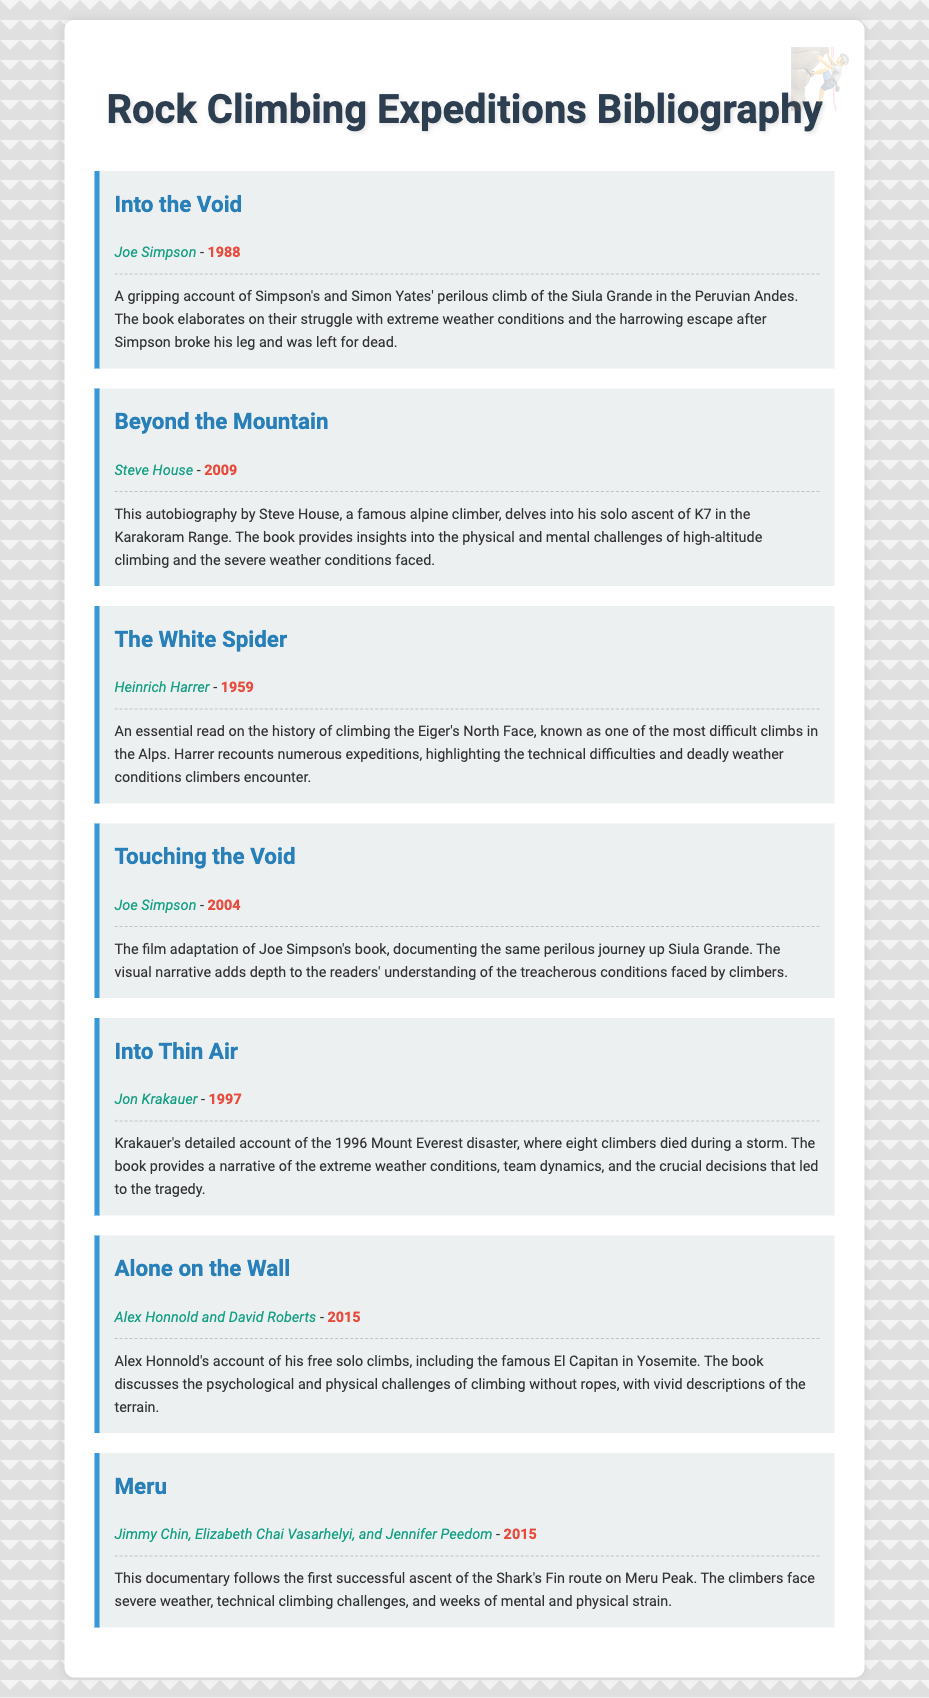What is the title of the book by Joe Simpson from 1988? The title of the book is mentioned first in the bibliographic entry.
Answer: Into the Void Who is the author of "Beyond the Mountain"? The author's name is provided directly beneath the title in the bibliographic entry.
Answer: Steve House In what year was "The White Spider" published? The year of publication is stated directly next to the author's name in the bibliographic entry.
Answer: 1959 What expedition does "Into Thin Air" describe? This book focuses on a specific event mentioned in the description, summarizing its content.
Answer: the 1996 Mount Everest disaster Which climber's free solo climbs are detailed in "Alone on the Wall"? The climber's name is given in the bibliographic entry, indicating the subject of the book.
Answer: Alex Honnold What film is an adaptation of Joe Simpson's work? The film's name is specified in the title of a bibliographic entry related to his book.
Answer: Touching the Void How many authors contributed to the book "Meru"? The number of authors can be counted from the bibliographic entry.
Answer: Three What common theme is present in both "Into the Void" and "Into Thin Air"? The challenges faced by climbers during their expeditions are discussed in both entries, providing a thematic connection.
Answer: climbers' challenges Which book features the ascent of K7 in the Karakoram Range? This specific detail is mentioned in the description of the relevant bibliographic entry.
Answer: Beyond the Mountain 